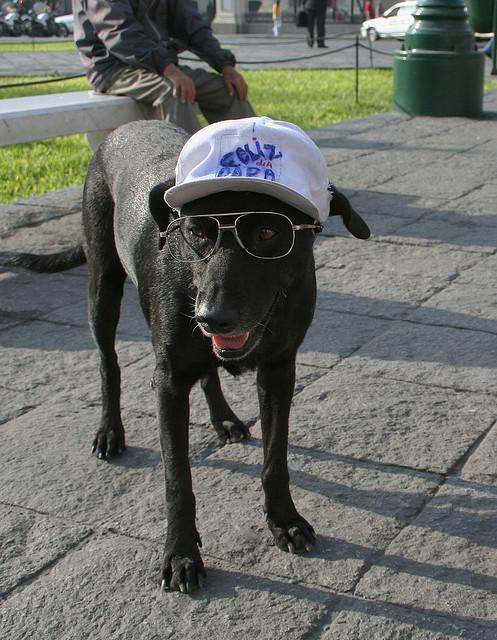How many baby elephants are there?
Give a very brief answer. 0. 